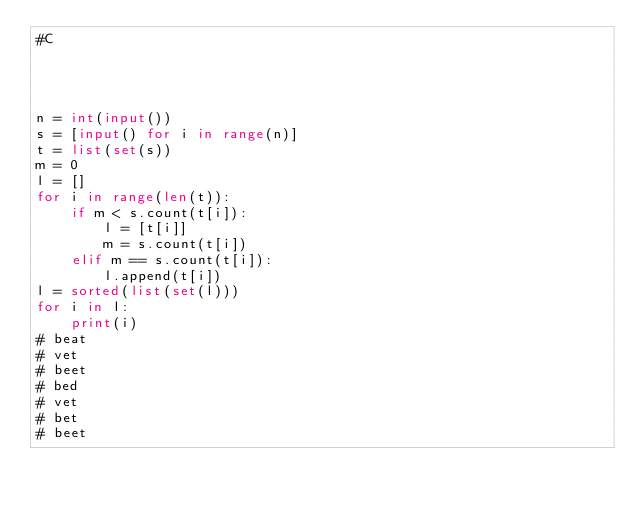Convert code to text. <code><loc_0><loc_0><loc_500><loc_500><_Python_>#C




n = int(input())
s = [input() for i in range(n)]
t = list(set(s))
m = 0
l = []
for i in range(len(t)):
    if m < s.count(t[i]):
        l = [t[i]]
        m = s.count(t[i])
    elif m == s.count(t[i]):
        l.append(t[i])
l = sorted(list(set(l)))
for i in l:
    print(i) 
# beat
# vet
# beet
# bed
# vet
# bet
# beet

</code> 